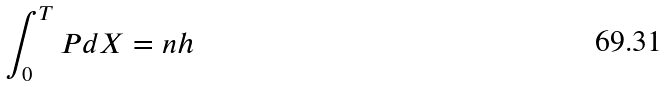Convert formula to latex. <formula><loc_0><loc_0><loc_500><loc_500>\int _ { 0 } ^ { T } P d X = n h</formula> 